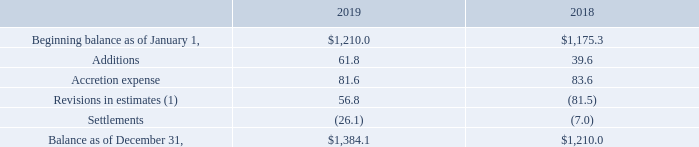AMERICAN TOWER CORPORATION AND SUBSIDIARIES NOTES TO CONSOLIDATED FINANCIAL STATEMENT(Tabular amounts in millions, unless otherwise disclosed)
11. ASSET RETIREMENT OBLIGATIONS
The changes in the carrying amount of the Company’s asset retirement obligations were as follows:
(1) Revisions in estimates include decreases to the liability of $6.7 million and $49.4 million related to foreign currency translation for the years ended December 31, 2019 and 2018, respectively.
As of December 31, 2019, the estimated undiscounted future cash outlay for asset retirement obligations was $3.2 billion.
As of December 31, 2019, what was the estimated undiscounted future cash outlay for asset retirement obligations? $3.2 billion. How much were the decreases to the liability included in the revisions in estimates by the company in 2019 and 2018 respectively? $6.7 million, 49.4 million. What was the accretion expense in 2019?
Answer scale should be: million. 81.6. What was the change in balance as of December 31 between 2018 and 2019?
Answer scale should be: million. $1,384.1-$1,210.0
Answer: 174.1. What is the sum of additions and accretion expense in 2018?
Answer scale should be: million. 39.6+83.6
Answer: 123.2. What is the percentage change in settlements between 2018 and 2019?
Answer scale should be: percent. (-26.1-(-7.0))/-7.0
Answer: 272.86. 